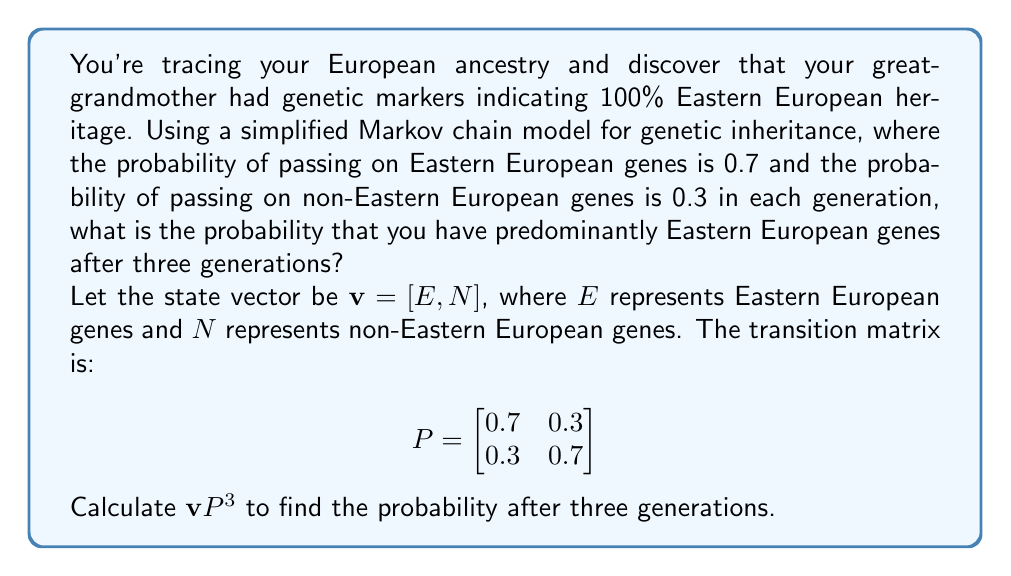Can you solve this math problem? Let's solve this step-by-step:

1) The initial state vector is $\mathbf{v}_0 = [1, 0]$ because your great-grandmother was 100% Eastern European.

2) We need to calculate $\mathbf{v}_0P^3$. Let's start by calculating $P^2$ and $P^3$:

   $P^2 = P \cdot P = \begin{bmatrix}
   0.7 & 0.3 \\
   0.3 & 0.7
   \end{bmatrix} \cdot \begin{bmatrix}
   0.7 & 0.3 \\
   0.3 & 0.7
   \end{bmatrix} = \begin{bmatrix}
   0.58 & 0.42 \\
   0.42 & 0.58
   \end{bmatrix}$

   $P^3 = P^2 \cdot P = \begin{bmatrix}
   0.58 & 0.42 \\
   0.42 & 0.58
   \end{bmatrix} \cdot \begin{bmatrix}
   0.7 & 0.3 \\
   0.3 & 0.7
   \end{bmatrix} = \begin{bmatrix}
   0.526 & 0.474 \\
   0.474 & 0.526
   \end{bmatrix}$

3) Now we can calculate $\mathbf{v}_0P^3$:

   $\mathbf{v}_0P^3 = [1, 0] \cdot \begin{bmatrix}
   0.526 & 0.474 \\
   0.474 & 0.526
   \end{bmatrix} = [0.526, 0.474]$

4) The first element of this resulting vector (0.526) represents the probability of having predominantly Eastern European genes after three generations.
Answer: 0.526 or 52.6% 